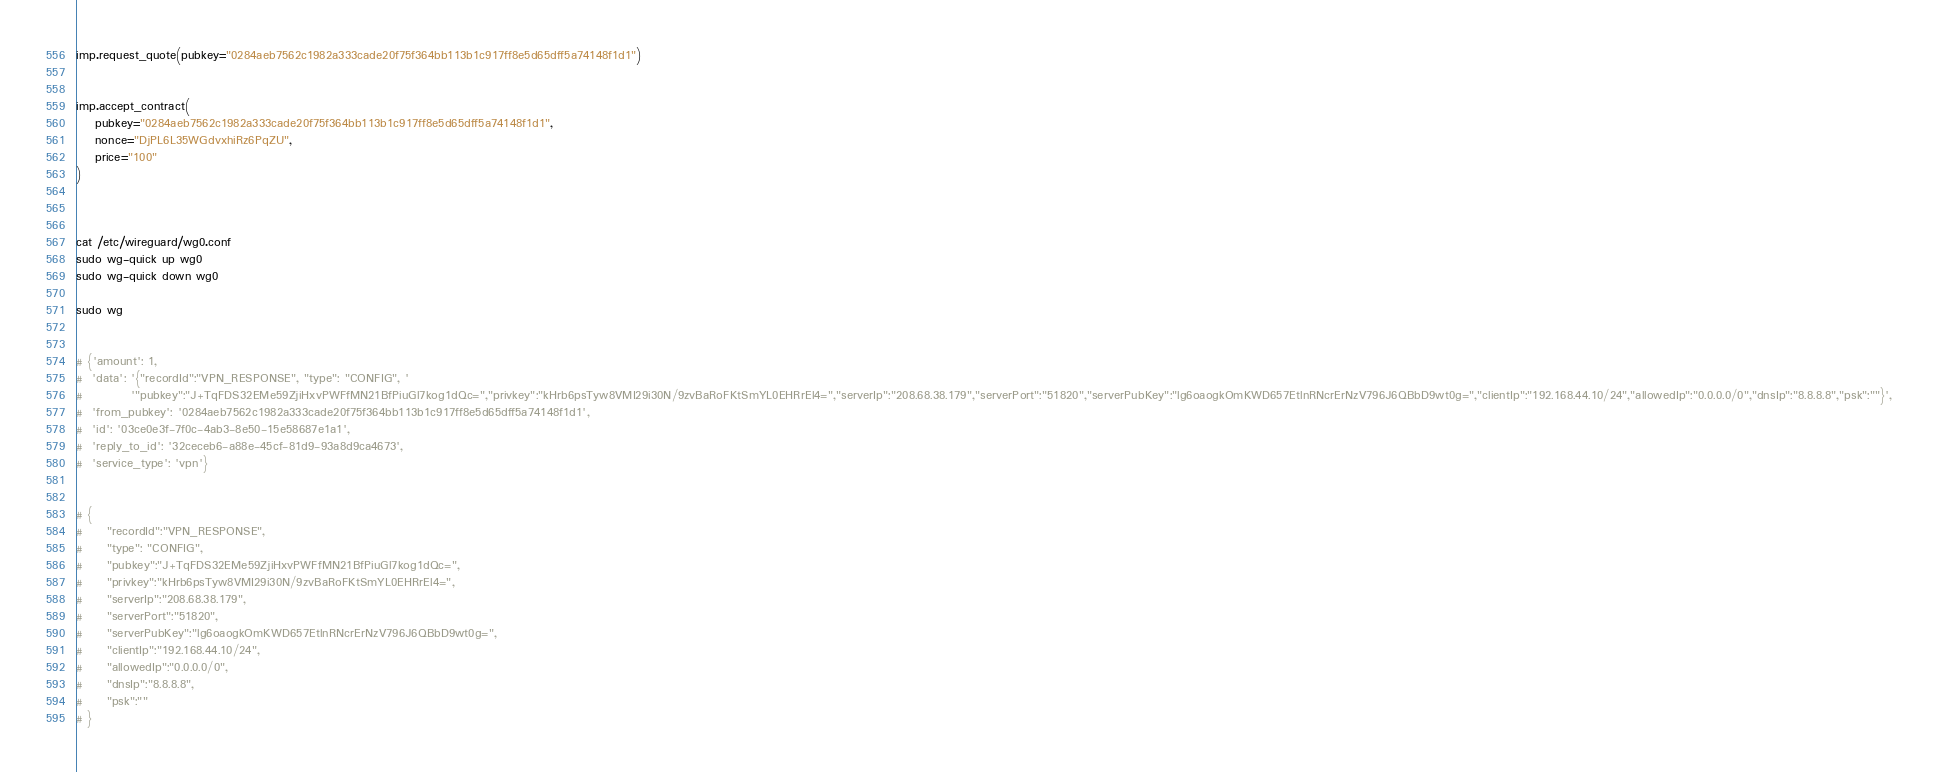Convert code to text. <code><loc_0><loc_0><loc_500><loc_500><_Python_>imp.request_quote(pubkey="0284aeb7562c1982a333cade20f75f364bb113b1c917ff8e5d65dff5a74148f1d1")


imp.accept_contract(
    pubkey="0284aeb7562c1982a333cade20f75f364bb113b1c917ff8e5d65dff5a74148f1d1",
    nonce="DjPL6L35WGdvxhiRz6PqZU",
    price="100"
)



cat /etc/wireguard/wg0.conf
sudo wg-quick up wg0
sudo wg-quick down wg0

sudo wg


# {'amount': 1,
#  'data': '{"recordId":"VPN_RESPONSE", "type": "CONFIG", '
#          '"pubkey":"J+TqFDS32EMe59ZjiHxvPWFfMN21BfPiuGl7kog1dQc=","privkey":"kHrb6psTyw8VMI29i30N/9zvBaRoFKtSmYL0EHRrEl4=","serverIp":"208.68.38.179","serverPort":"51820","serverPubKey":"lg6oaogkOmKWD657EtlnRNcrErNzV796J6QBbD9wt0g=","clientIp":"192.168.44.10/24","allowedIp":"0.0.0.0/0","dnsIp":"8.8.8.8","psk":""}',
#  'from_pubkey': '0284aeb7562c1982a333cade20f75f364bb113b1c917ff8e5d65dff5a74148f1d1',
#  'id': '03ce0e3f-7f0c-4ab3-8e50-15e58687e1a1',
#  'reply_to_id': '32ceceb6-a88e-45cf-81d9-93a8d9ca4673',
#  'service_type': 'vpn'}


# {
#     "recordId":"VPN_RESPONSE", 
#     "type": "CONFIG",
#     "pubkey":"J+TqFDS32EMe59ZjiHxvPWFfMN21BfPiuGl7kog1dQc=",
#     "privkey":"kHrb6psTyw8VMI29i30N/9zvBaRoFKtSmYL0EHRrEl4=",
#     "serverIp":"208.68.38.179",
#     "serverPort":"51820",
#     "serverPubKey":"lg6oaogkOmKWD657EtlnRNcrErNzV796J6QBbD9wt0g=",
#     "clientIp":"192.168.44.10/24",
#     "allowedIp":"0.0.0.0/0",
#     "dnsIp":"8.8.8.8",
#     "psk":""
# }</code> 